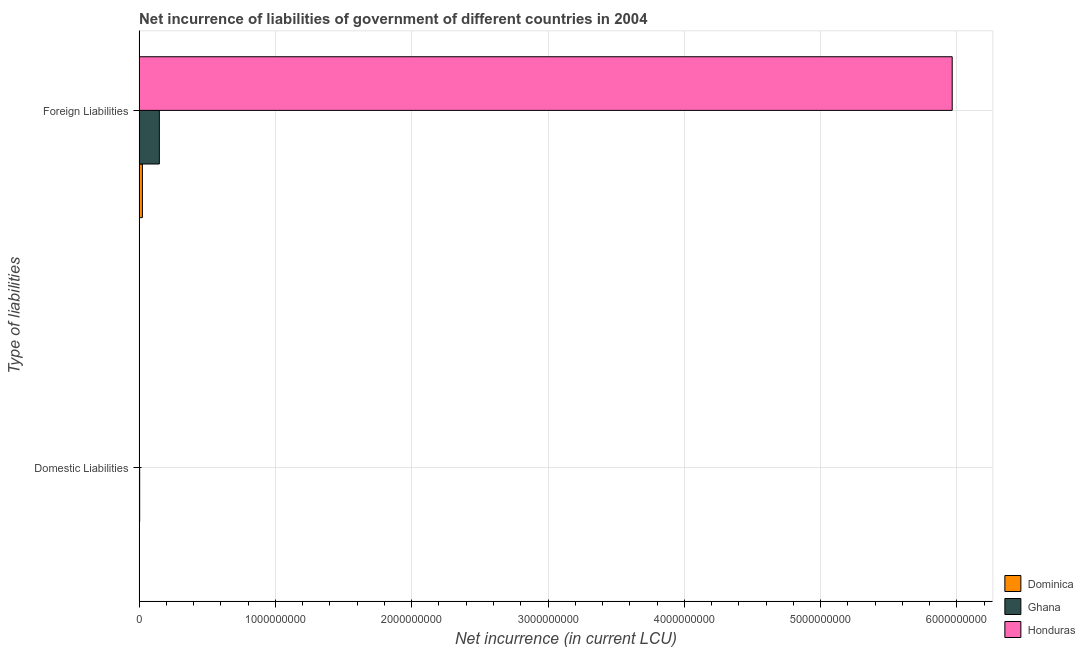How many different coloured bars are there?
Your response must be concise. 3. Are the number of bars on each tick of the Y-axis equal?
Your response must be concise. No. How many bars are there on the 1st tick from the bottom?
Give a very brief answer. 1. What is the label of the 2nd group of bars from the top?
Your answer should be compact. Domestic Liabilities. What is the net incurrence of domestic liabilities in Ghana?
Give a very brief answer. 4.23e+06. Across all countries, what is the maximum net incurrence of foreign liabilities?
Ensure brevity in your answer.  5.97e+09. Across all countries, what is the minimum net incurrence of foreign liabilities?
Make the answer very short. 2.42e+07. In which country was the net incurrence of foreign liabilities maximum?
Provide a succinct answer. Honduras. What is the total net incurrence of foreign liabilities in the graph?
Offer a very short reply. 6.14e+09. What is the difference between the net incurrence of foreign liabilities in Ghana and that in Dominica?
Keep it short and to the point. 1.24e+08. What is the difference between the net incurrence of domestic liabilities in Ghana and the net incurrence of foreign liabilities in Honduras?
Ensure brevity in your answer.  -5.96e+09. What is the average net incurrence of foreign liabilities per country?
Your answer should be very brief. 2.05e+09. What is the difference between the net incurrence of domestic liabilities and net incurrence of foreign liabilities in Ghana?
Offer a very short reply. -1.44e+08. What is the ratio of the net incurrence of foreign liabilities in Honduras to that in Ghana?
Your answer should be compact. 40.16. How many bars are there?
Make the answer very short. 4. What is the difference between two consecutive major ticks on the X-axis?
Offer a very short reply. 1.00e+09. Are the values on the major ticks of X-axis written in scientific E-notation?
Offer a very short reply. No. Where does the legend appear in the graph?
Provide a succinct answer. Bottom right. How many legend labels are there?
Your response must be concise. 3. What is the title of the graph?
Offer a very short reply. Net incurrence of liabilities of government of different countries in 2004. What is the label or title of the X-axis?
Provide a succinct answer. Net incurrence (in current LCU). What is the label or title of the Y-axis?
Make the answer very short. Type of liabilities. What is the Net incurrence (in current LCU) of Dominica in Domestic Liabilities?
Your answer should be compact. 0. What is the Net incurrence (in current LCU) in Ghana in Domestic Liabilities?
Give a very brief answer. 4.23e+06. What is the Net incurrence (in current LCU) of Dominica in Foreign Liabilities?
Ensure brevity in your answer.  2.42e+07. What is the Net incurrence (in current LCU) in Ghana in Foreign Liabilities?
Your answer should be very brief. 1.49e+08. What is the Net incurrence (in current LCU) of Honduras in Foreign Liabilities?
Your response must be concise. 5.97e+09. Across all Type of liabilities, what is the maximum Net incurrence (in current LCU) in Dominica?
Offer a very short reply. 2.42e+07. Across all Type of liabilities, what is the maximum Net incurrence (in current LCU) of Ghana?
Your answer should be very brief. 1.49e+08. Across all Type of liabilities, what is the maximum Net incurrence (in current LCU) in Honduras?
Keep it short and to the point. 5.97e+09. Across all Type of liabilities, what is the minimum Net incurrence (in current LCU) in Ghana?
Make the answer very short. 4.23e+06. Across all Type of liabilities, what is the minimum Net incurrence (in current LCU) of Honduras?
Your answer should be very brief. 0. What is the total Net incurrence (in current LCU) in Dominica in the graph?
Your answer should be compact. 2.42e+07. What is the total Net incurrence (in current LCU) in Ghana in the graph?
Ensure brevity in your answer.  1.53e+08. What is the total Net incurrence (in current LCU) in Honduras in the graph?
Provide a succinct answer. 5.97e+09. What is the difference between the Net incurrence (in current LCU) in Ghana in Domestic Liabilities and that in Foreign Liabilities?
Your answer should be very brief. -1.44e+08. What is the difference between the Net incurrence (in current LCU) of Ghana in Domestic Liabilities and the Net incurrence (in current LCU) of Honduras in Foreign Liabilities?
Offer a very short reply. -5.96e+09. What is the average Net incurrence (in current LCU) in Dominica per Type of liabilities?
Give a very brief answer. 1.21e+07. What is the average Net incurrence (in current LCU) in Ghana per Type of liabilities?
Your response must be concise. 7.64e+07. What is the average Net incurrence (in current LCU) of Honduras per Type of liabilities?
Provide a succinct answer. 2.98e+09. What is the difference between the Net incurrence (in current LCU) in Dominica and Net incurrence (in current LCU) in Ghana in Foreign Liabilities?
Ensure brevity in your answer.  -1.24e+08. What is the difference between the Net incurrence (in current LCU) in Dominica and Net incurrence (in current LCU) in Honduras in Foreign Liabilities?
Your response must be concise. -5.94e+09. What is the difference between the Net incurrence (in current LCU) in Ghana and Net incurrence (in current LCU) in Honduras in Foreign Liabilities?
Provide a succinct answer. -5.82e+09. What is the ratio of the Net incurrence (in current LCU) of Ghana in Domestic Liabilities to that in Foreign Liabilities?
Offer a terse response. 0.03. What is the difference between the highest and the second highest Net incurrence (in current LCU) in Ghana?
Offer a very short reply. 1.44e+08. What is the difference between the highest and the lowest Net incurrence (in current LCU) of Dominica?
Provide a short and direct response. 2.42e+07. What is the difference between the highest and the lowest Net incurrence (in current LCU) in Ghana?
Ensure brevity in your answer.  1.44e+08. What is the difference between the highest and the lowest Net incurrence (in current LCU) of Honduras?
Your response must be concise. 5.97e+09. 